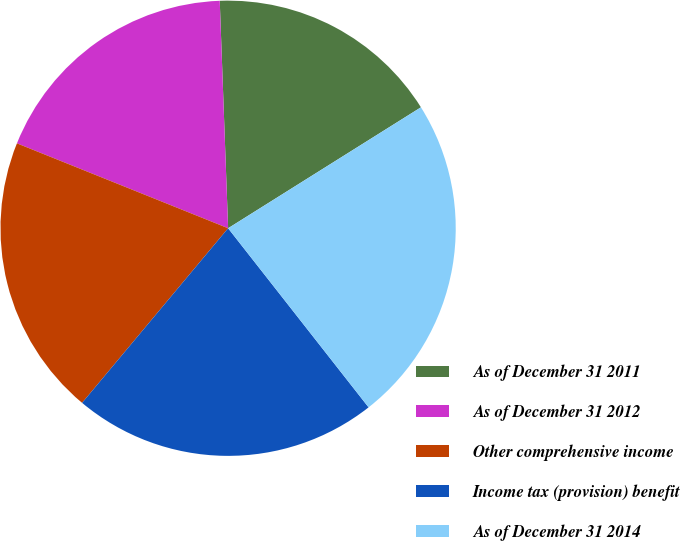<chart> <loc_0><loc_0><loc_500><loc_500><pie_chart><fcel>As of December 31 2011<fcel>As of December 31 2012<fcel>Other comprehensive income<fcel>Income tax (provision) benefit<fcel>As of December 31 2014<nl><fcel>16.67%<fcel>18.33%<fcel>20.0%<fcel>21.67%<fcel>23.33%<nl></chart> 